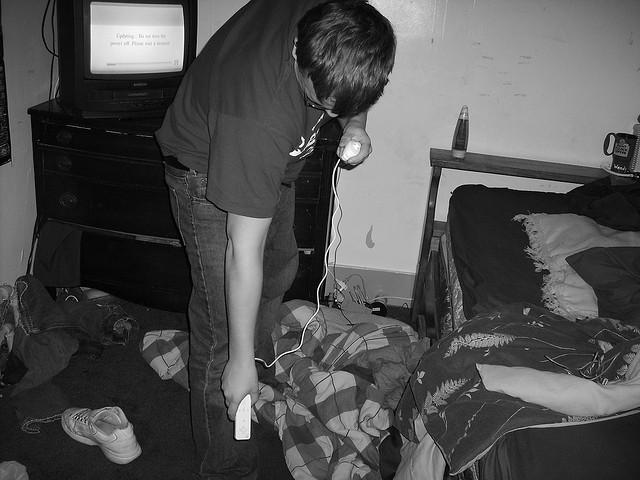What is the video game console connected to the television currently doing? updating 